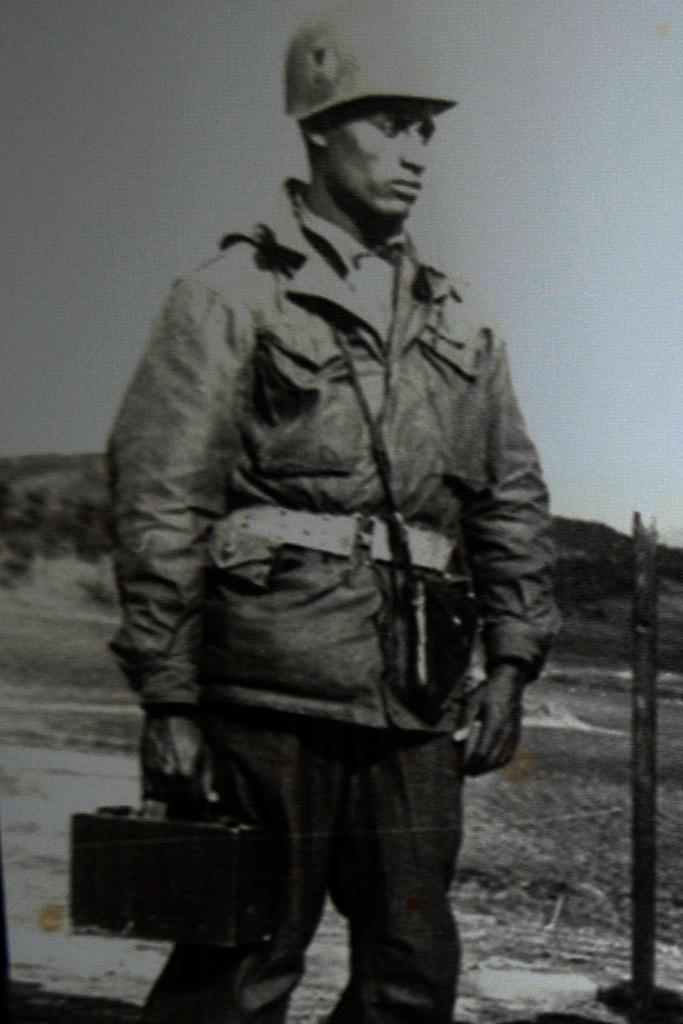Who is the main subject in the image? There is a man in the center of the image. What is the man doing in the image? The man is standing and holding a suitcase. What can be seen in the background of the image? There are mountains in the background of the image. What object is on the right side of the image? There is a pole on the right side of the image. What type of lamp is hanging from the pole in the image? There is no lamp present in the image; only a pole can be seen on the right side. 